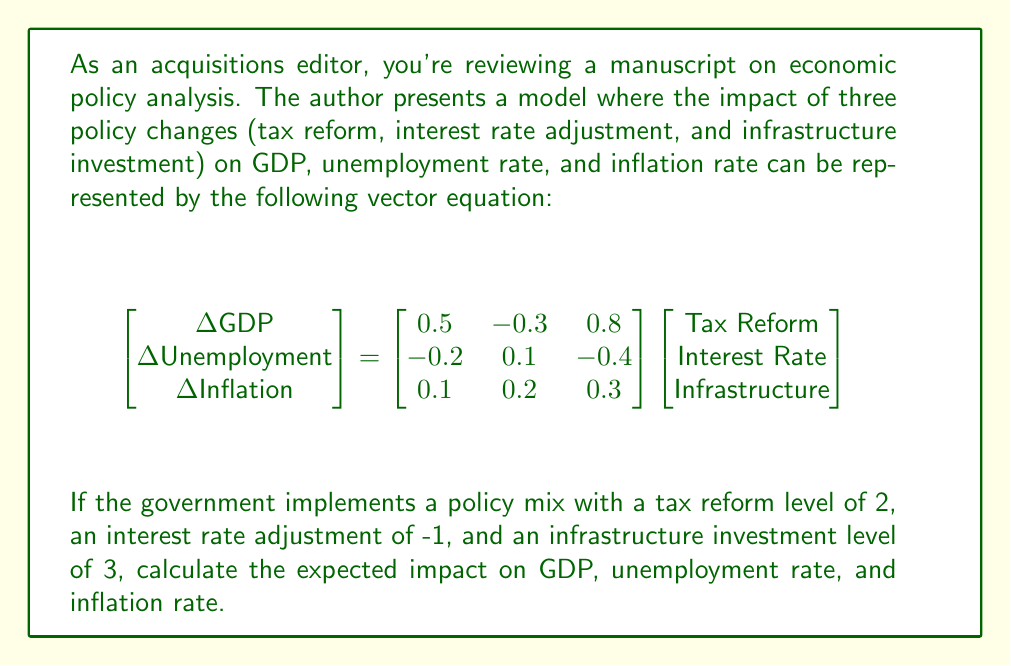Show me your answer to this math problem. To solve this problem, we need to perform matrix multiplication between the impact matrix and the policy vector. Let's break it down step-by-step:

1) First, let's identify our matrices:
   Impact matrix: $$A = \begin{bmatrix} 0.5 & -0.3 & 0.8 \\ -0.2 & 0.1 & -0.4 \\ 0.1 & 0.2 & 0.3 \end{bmatrix}$$
   Policy vector: $$\vec{p} = \begin{bmatrix} 2 \\ -1 \\ 3 \end{bmatrix}$$

2) We need to calculate $A\vec{p}$. Let's do this row by row:

   For GDP impact:
   $$(0.5 \times 2) + (-0.3 \times -1) + (0.8 \times 3) = 1 + 0.3 + 2.4 = 3.7$$

   For Unemployment impact:
   $$(-0.2 \times 2) + (0.1 \times -1) + (-0.4 \times 3) = -0.4 - 0.1 - 1.2 = -1.7$$

   For Inflation impact:
   $$(0.1 \times 2) + (0.2 \times -1) + (0.3 \times 3) = 0.2 - 0.2 + 0.9 = 0.9$$

3) Therefore, the result of our matrix multiplication is:
   $$\begin{bmatrix} \Delta GDP \\ \Delta Unemployment \\ \Delta Inflation \end{bmatrix} = \begin{bmatrix} 3.7 \\ -1.7 \\ 0.9 \end{bmatrix}$$

This means that the policy mix is expected to increase GDP by 3.7 units, decrease unemployment by 1.7 units, and increase inflation by 0.9 units.
Answer: $$\begin{bmatrix} 3.7 \\ -1.7 \\ 0.9 \end{bmatrix}$$ 